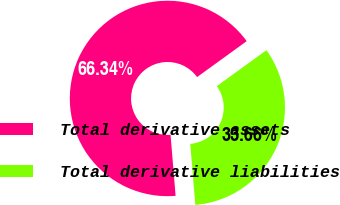Convert chart to OTSL. <chart><loc_0><loc_0><loc_500><loc_500><pie_chart><fcel>Total derivative assets<fcel>Total derivative liabilities<nl><fcel>66.34%<fcel>33.66%<nl></chart> 